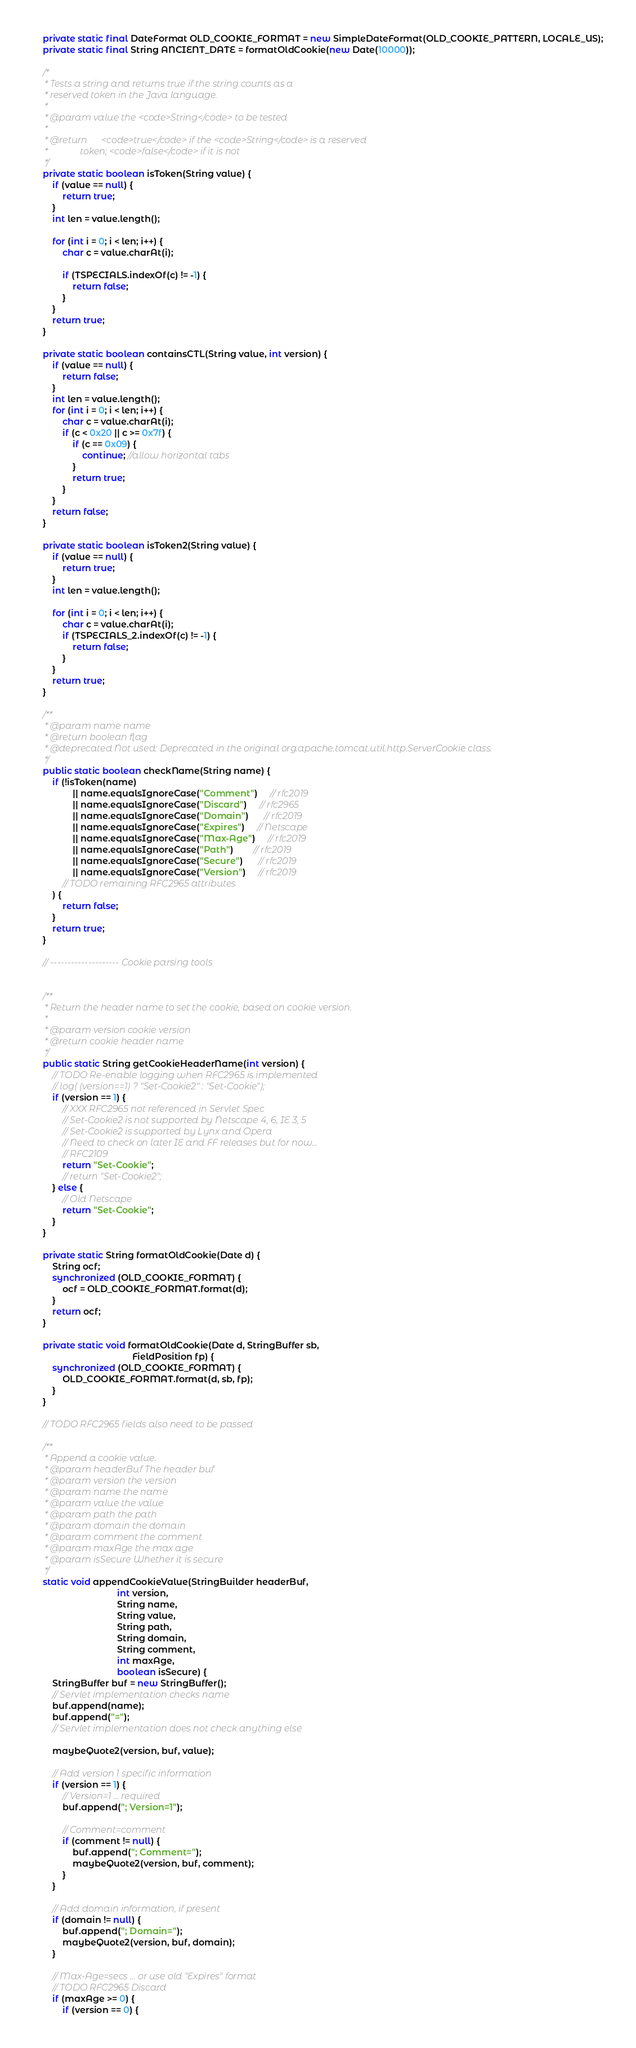<code> <loc_0><loc_0><loc_500><loc_500><_Java_>    private static final DateFormat OLD_COOKIE_FORMAT = new SimpleDateFormat(OLD_COOKIE_PATTERN, LOCALE_US);
    private static final String ANCIENT_DATE = formatOldCookie(new Date(10000));

    /*
     * Tests a string and returns true if the string counts as a
     * reserved token in the Java language.
     *
     * @param value the <code>String</code> to be tested
     *
     * @return      <code>true</code> if the <code>String</code> is a reserved
     *              token; <code>false</code> if it is not
     */
    private static boolean isToken(String value) {
        if (value == null) {
            return true;
        }
        int len = value.length();

        for (int i = 0; i < len; i++) {
            char c = value.charAt(i);

            if (TSPECIALS.indexOf(c) != -1) {
                return false;
            }
        }
        return true;
    }

    private static boolean containsCTL(String value, int version) {
        if (value == null) {
            return false;
        }
        int len = value.length();
        for (int i = 0; i < len; i++) {
            char c = value.charAt(i);
            if (c < 0x20 || c >= 0x7f) {
                if (c == 0x09) {
                    continue; //allow horizontal tabs
                }
                return true;
            }
        }
        return false;
    }

    private static boolean isToken2(String value) {
        if (value == null) {
            return true;
        }
        int len = value.length();

        for (int i = 0; i < len; i++) {
            char c = value.charAt(i);
            if (TSPECIALS_2.indexOf(c) != -1) {
                return false;
            }
        }
        return true;
    }

    /**
     * @param name name
     * @return boolean flag
     * @deprecated Not used: Deprecated in the original org.apache.tomcat.util.http.ServerCookie class.
     */
    public static boolean checkName(String name) {
        if (!isToken(name)
                || name.equalsIgnoreCase("Comment")     // rfc2019
                || name.equalsIgnoreCase("Discard")     // rfc2965
                || name.equalsIgnoreCase("Domain")      // rfc2019
                || name.equalsIgnoreCase("Expires")     // Netscape
                || name.equalsIgnoreCase("Max-Age")     // rfc2019
                || name.equalsIgnoreCase("Path")        // rfc2019
                || name.equalsIgnoreCase("Secure")      // rfc2019
                || name.equalsIgnoreCase("Version")     // rfc2019
            // TODO remaining RFC2965 attributes
        ) {
            return false;
        }
        return true;
    }

    // -------------------- Cookie parsing tools


    /**
     * Return the header name to set the cookie, based on cookie version.
     *
     * @param version cookie version
     * @return cookie header name
     */
    public static String getCookieHeaderName(int version) {
        // TODO Re-enable logging when RFC2965 is implemented
        // log( (version==1) ? "Set-Cookie2" : "Set-Cookie");
        if (version == 1) {
            // XXX RFC2965 not referenced in Servlet Spec
            // Set-Cookie2 is not supported by Netscape 4, 6, IE 3, 5
            // Set-Cookie2 is supported by Lynx and Opera
            // Need to check on later IE and FF releases but for now...
            // RFC2109
            return "Set-Cookie";
            // return "Set-Cookie2";
        } else {
            // Old Netscape
            return "Set-Cookie";
        }
    }

    private static String formatOldCookie(Date d) {
        String ocf;
        synchronized (OLD_COOKIE_FORMAT) {
            ocf = OLD_COOKIE_FORMAT.format(d);
        }
        return ocf;
    }

    private static void formatOldCookie(Date d, StringBuffer sb,
                                        FieldPosition fp) {
        synchronized (OLD_COOKIE_FORMAT) {
            OLD_COOKIE_FORMAT.format(d, sb, fp);
        }
    }

    // TODO RFC2965 fields also need to be passed

    /**
     * Append a cookie value.
     * @param headerBuf The header buf
     * @param version the version
     * @param name the name
     * @param value the value
     * @param path the path
     * @param domain the domain
     * @param comment the comment
     * @param maxAge the max age
     * @param isSecure Whether it is secure
     */
    static void appendCookieValue(StringBuilder headerBuf,
                                  int version,
                                  String name,
                                  String value,
                                  String path,
                                  String domain,
                                  String comment,
                                  int maxAge,
                                  boolean isSecure) {
        StringBuffer buf = new StringBuffer();
        // Servlet implementation checks name
        buf.append(name);
        buf.append("=");
        // Servlet implementation does not check anything else

        maybeQuote2(version, buf, value);

        // Add version 1 specific information
        if (version == 1) {
            // Version=1 ... required
            buf.append("; Version=1");

            // Comment=comment
            if (comment != null) {
                buf.append("; Comment=");
                maybeQuote2(version, buf, comment);
            }
        }

        // Add domain information, if present
        if (domain != null) {
            buf.append("; Domain=");
            maybeQuote2(version, buf, domain);
        }

        // Max-Age=secs ... or use old "Expires" format
        // TODO RFC2965 Discard
        if (maxAge >= 0) {
            if (version == 0) {</code> 